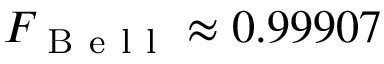Convert formula to latex. <formula><loc_0><loc_0><loc_500><loc_500>F _ { B e l l } \approx 0 . 9 9 9 0 7</formula> 